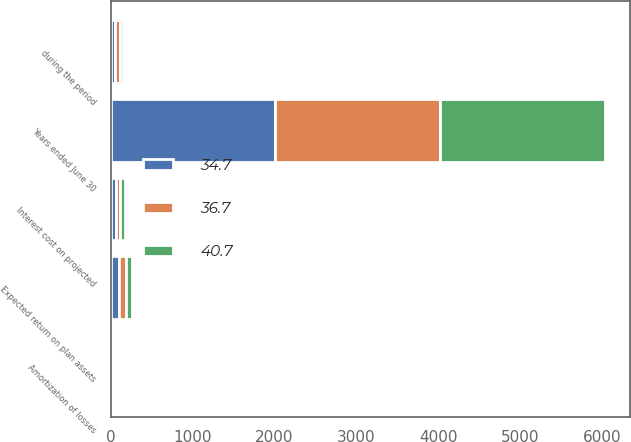<chart> <loc_0><loc_0><loc_500><loc_500><stacked_bar_chart><ecel><fcel>Years ended June 30<fcel>during the period<fcel>Interest cost on projected<fcel>Expected return on plan assets<fcel>Amortization of losses<nl><fcel>34.7<fcel>2012<fcel>57.2<fcel>62.1<fcel>97.6<fcel>15<nl><fcel>36.7<fcel>2011<fcel>52.5<fcel>56.6<fcel>88.5<fcel>20.1<nl><fcel>40.7<fcel>2010<fcel>47.6<fcel>59.1<fcel>76.5<fcel>4.5<nl></chart> 